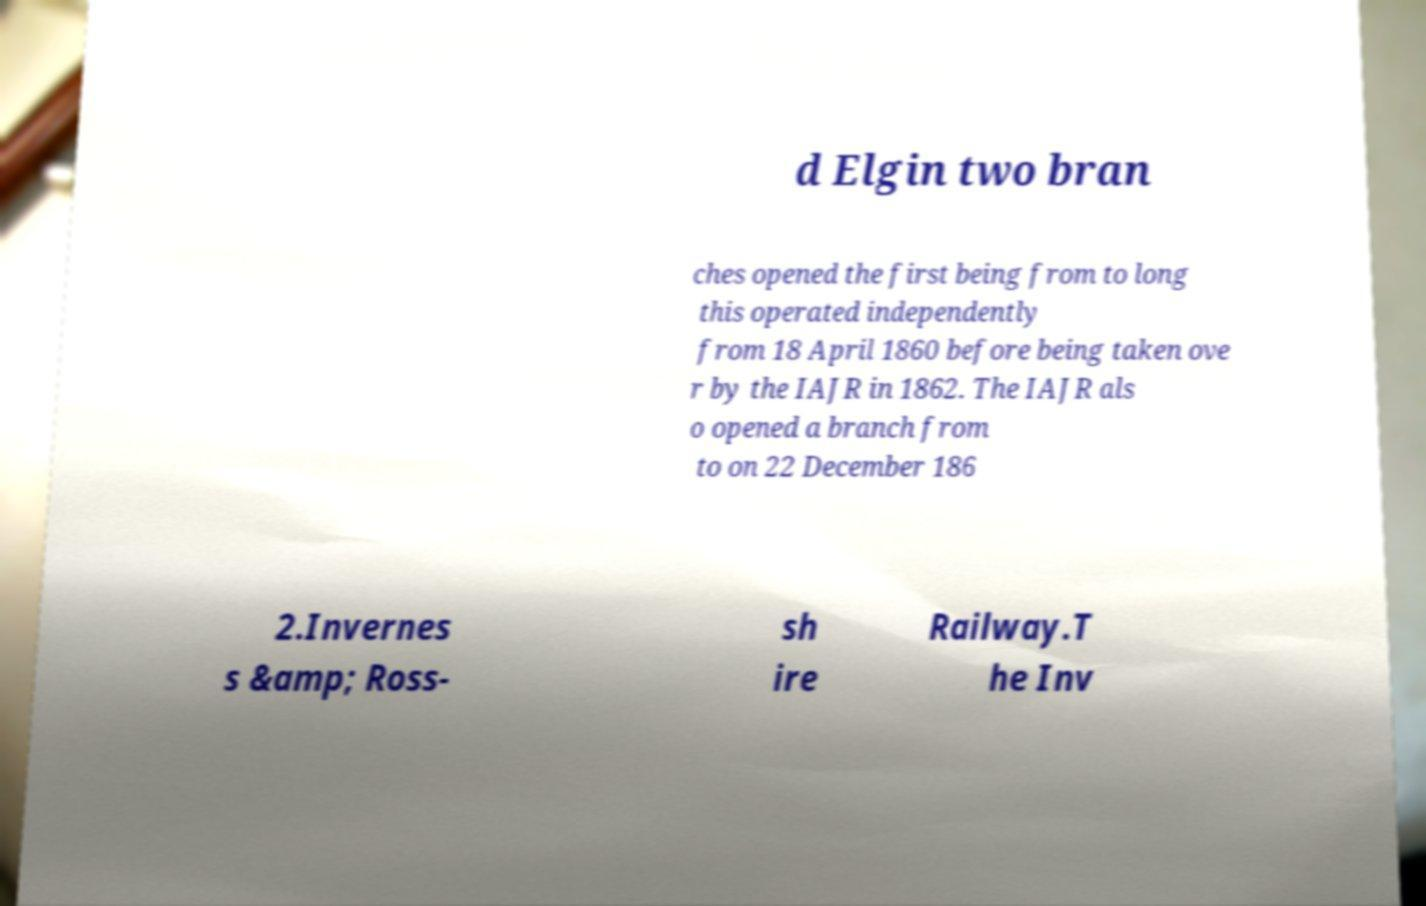Could you extract and type out the text from this image? d Elgin two bran ches opened the first being from to long this operated independently from 18 April 1860 before being taken ove r by the IAJR in 1862. The IAJR als o opened a branch from to on 22 December 186 2.Invernes s &amp; Ross- sh ire Railway.T he Inv 